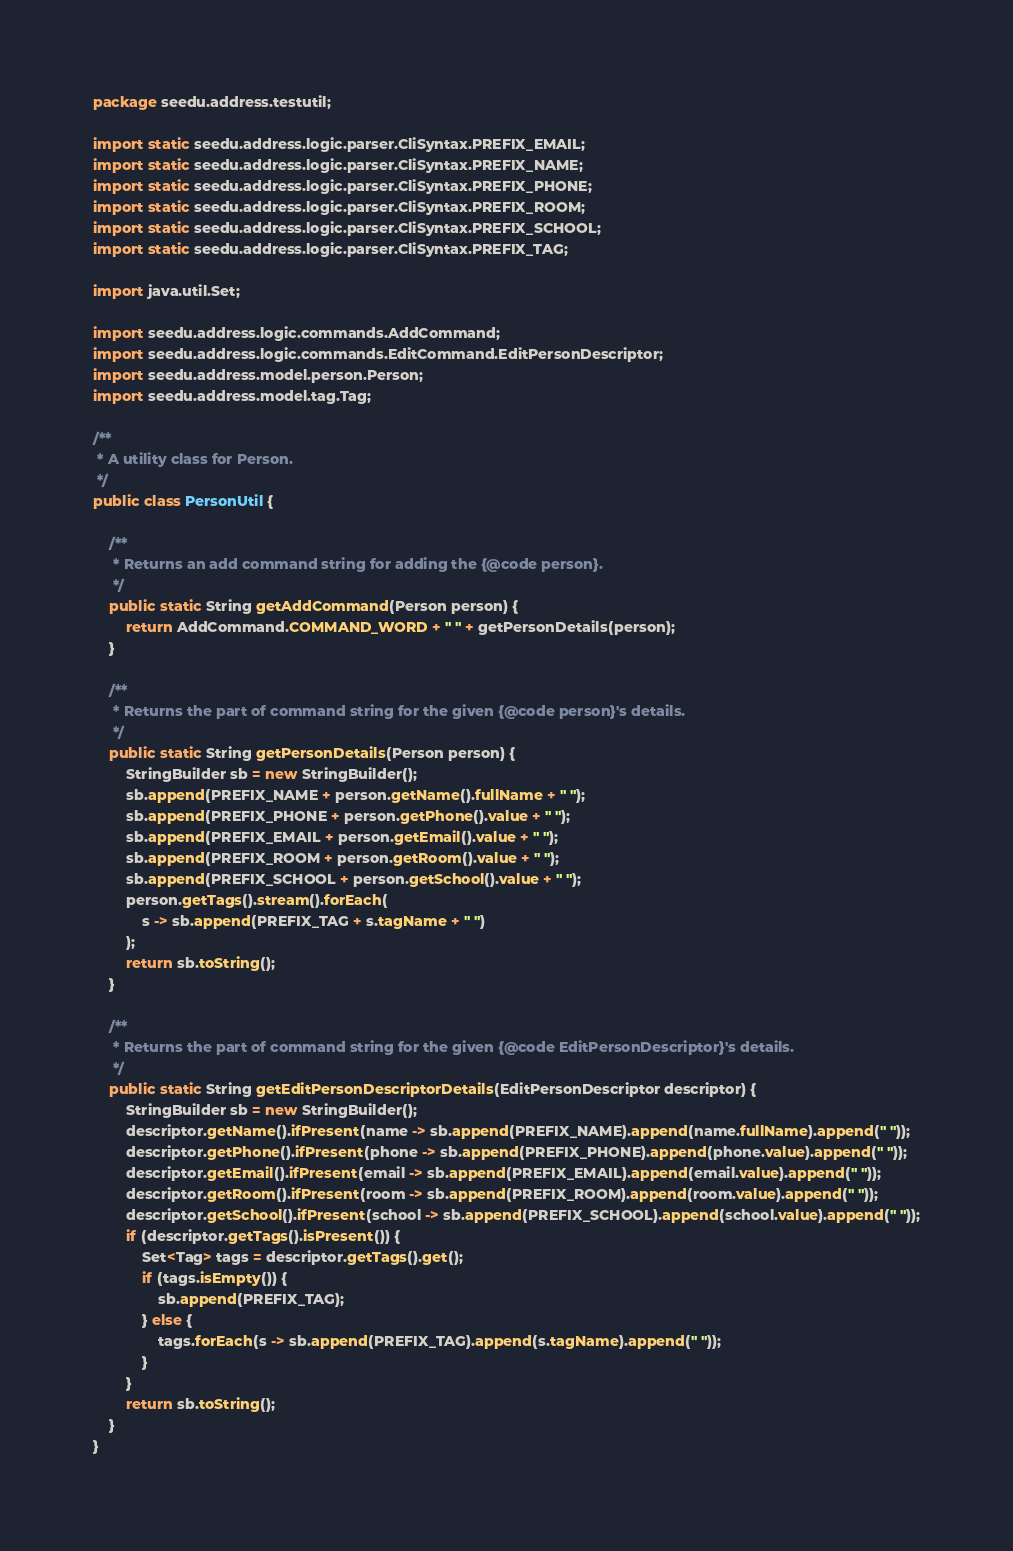<code> <loc_0><loc_0><loc_500><loc_500><_Java_>package seedu.address.testutil;

import static seedu.address.logic.parser.CliSyntax.PREFIX_EMAIL;
import static seedu.address.logic.parser.CliSyntax.PREFIX_NAME;
import static seedu.address.logic.parser.CliSyntax.PREFIX_PHONE;
import static seedu.address.logic.parser.CliSyntax.PREFIX_ROOM;
import static seedu.address.logic.parser.CliSyntax.PREFIX_SCHOOL;
import static seedu.address.logic.parser.CliSyntax.PREFIX_TAG;

import java.util.Set;

import seedu.address.logic.commands.AddCommand;
import seedu.address.logic.commands.EditCommand.EditPersonDescriptor;
import seedu.address.model.person.Person;
import seedu.address.model.tag.Tag;

/**
 * A utility class for Person.
 */
public class PersonUtil {

    /**
     * Returns an add command string for adding the {@code person}.
     */
    public static String getAddCommand(Person person) {
        return AddCommand.COMMAND_WORD + " " + getPersonDetails(person);
    }

    /**
     * Returns the part of command string for the given {@code person}'s details.
     */
    public static String getPersonDetails(Person person) {
        StringBuilder sb = new StringBuilder();
        sb.append(PREFIX_NAME + person.getName().fullName + " ");
        sb.append(PREFIX_PHONE + person.getPhone().value + " ");
        sb.append(PREFIX_EMAIL + person.getEmail().value + " ");
        sb.append(PREFIX_ROOM + person.getRoom().value + " ");
        sb.append(PREFIX_SCHOOL + person.getSchool().value + " ");
        person.getTags().stream().forEach(
            s -> sb.append(PREFIX_TAG + s.tagName + " ")
        );
        return sb.toString();
    }

    /**
     * Returns the part of command string for the given {@code EditPersonDescriptor}'s details.
     */
    public static String getEditPersonDescriptorDetails(EditPersonDescriptor descriptor) {
        StringBuilder sb = new StringBuilder();
        descriptor.getName().ifPresent(name -> sb.append(PREFIX_NAME).append(name.fullName).append(" "));
        descriptor.getPhone().ifPresent(phone -> sb.append(PREFIX_PHONE).append(phone.value).append(" "));
        descriptor.getEmail().ifPresent(email -> sb.append(PREFIX_EMAIL).append(email.value).append(" "));
        descriptor.getRoom().ifPresent(room -> sb.append(PREFIX_ROOM).append(room.value).append(" "));
        descriptor.getSchool().ifPresent(school -> sb.append(PREFIX_SCHOOL).append(school.value).append(" "));
        if (descriptor.getTags().isPresent()) {
            Set<Tag> tags = descriptor.getTags().get();
            if (tags.isEmpty()) {
                sb.append(PREFIX_TAG);
            } else {
                tags.forEach(s -> sb.append(PREFIX_TAG).append(s.tagName).append(" "));
            }
        }
        return sb.toString();
    }
}
</code> 